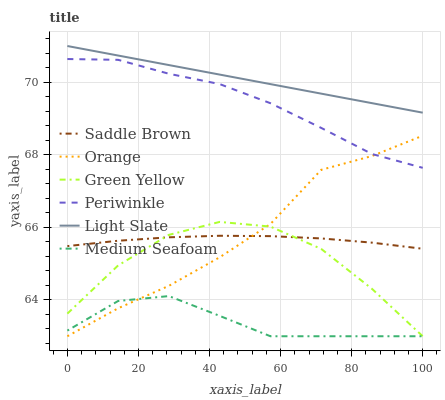Does Medium Seafoam have the minimum area under the curve?
Answer yes or no. Yes. Does Light Slate have the maximum area under the curve?
Answer yes or no. Yes. Does Periwinkle have the minimum area under the curve?
Answer yes or no. No. Does Periwinkle have the maximum area under the curve?
Answer yes or no. No. Is Light Slate the smoothest?
Answer yes or no. Yes. Is Green Yellow the roughest?
Answer yes or no. Yes. Is Medium Seafoam the smoothest?
Answer yes or no. No. Is Medium Seafoam the roughest?
Answer yes or no. No. Does Medium Seafoam have the lowest value?
Answer yes or no. Yes. Does Periwinkle have the lowest value?
Answer yes or no. No. Does Light Slate have the highest value?
Answer yes or no. Yes. Does Periwinkle have the highest value?
Answer yes or no. No. Is Green Yellow less than Light Slate?
Answer yes or no. Yes. Is Light Slate greater than Orange?
Answer yes or no. Yes. Does Orange intersect Medium Seafoam?
Answer yes or no. Yes. Is Orange less than Medium Seafoam?
Answer yes or no. No. Is Orange greater than Medium Seafoam?
Answer yes or no. No. Does Green Yellow intersect Light Slate?
Answer yes or no. No. 